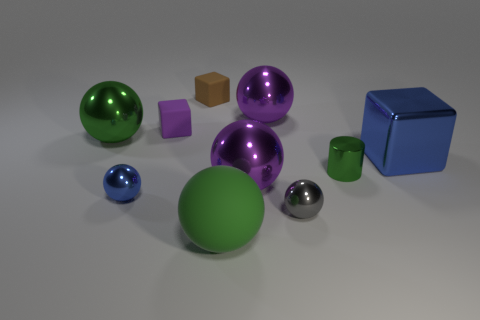Subtract all large spheres. How many spheres are left? 2 Subtract all green balls. How many balls are left? 4 Subtract all cylinders. How many objects are left? 9 Subtract 3 balls. How many balls are left? 3 Subtract 0 cyan blocks. How many objects are left? 10 Subtract all purple cubes. Subtract all blue spheres. How many cubes are left? 2 Subtract all yellow blocks. How many blue balls are left? 1 Subtract all tiny green shiny cylinders. Subtract all big shiny cubes. How many objects are left? 8 Add 9 green matte balls. How many green matte balls are left? 10 Add 6 tiny purple balls. How many tiny purple balls exist? 6 